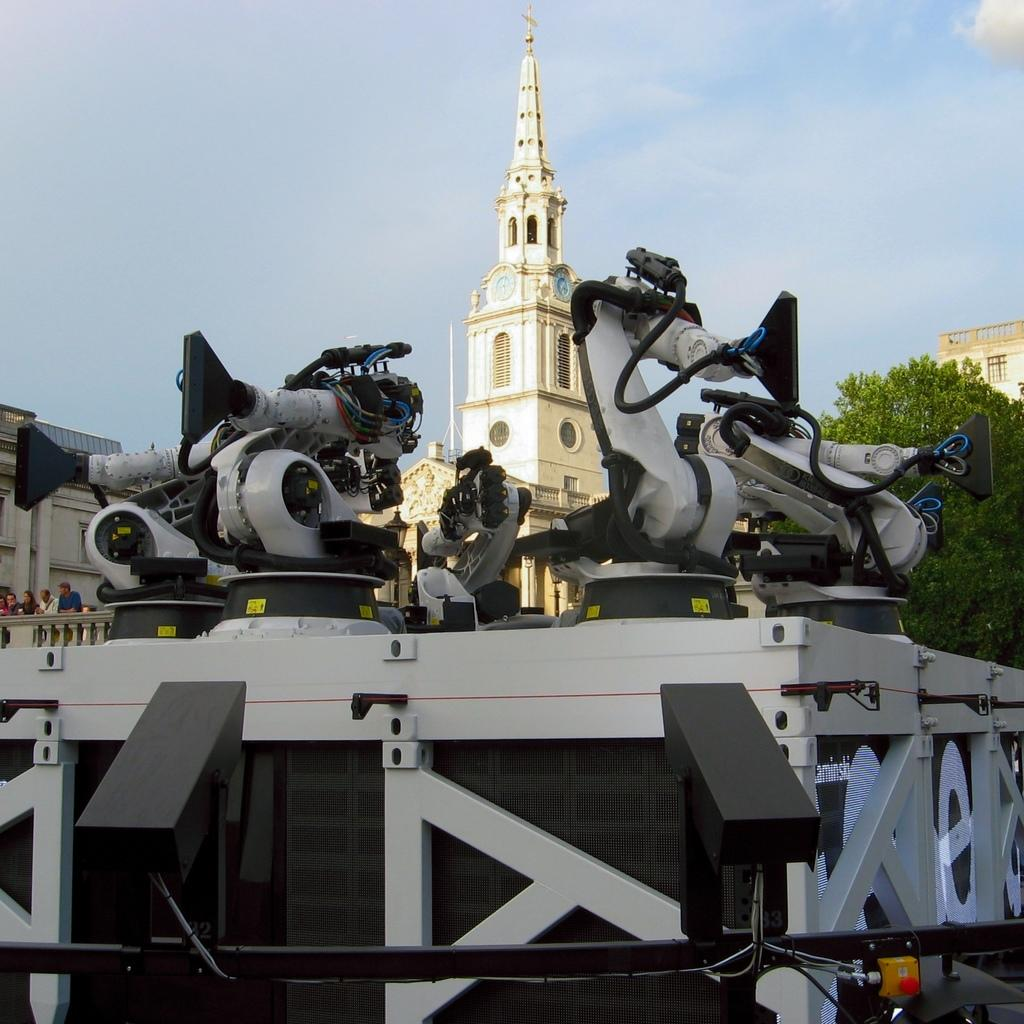What can be seen in the image? There are machines in the image, which are placed on an object. What is visible in the background of the image? There are buildings and a tree in the background of the image. Are there any people present in the image? Yes, there are people standing in the left corner of the image. Is there a curtain surrounding the machines in the image? No, there is no curtain present in the image. 